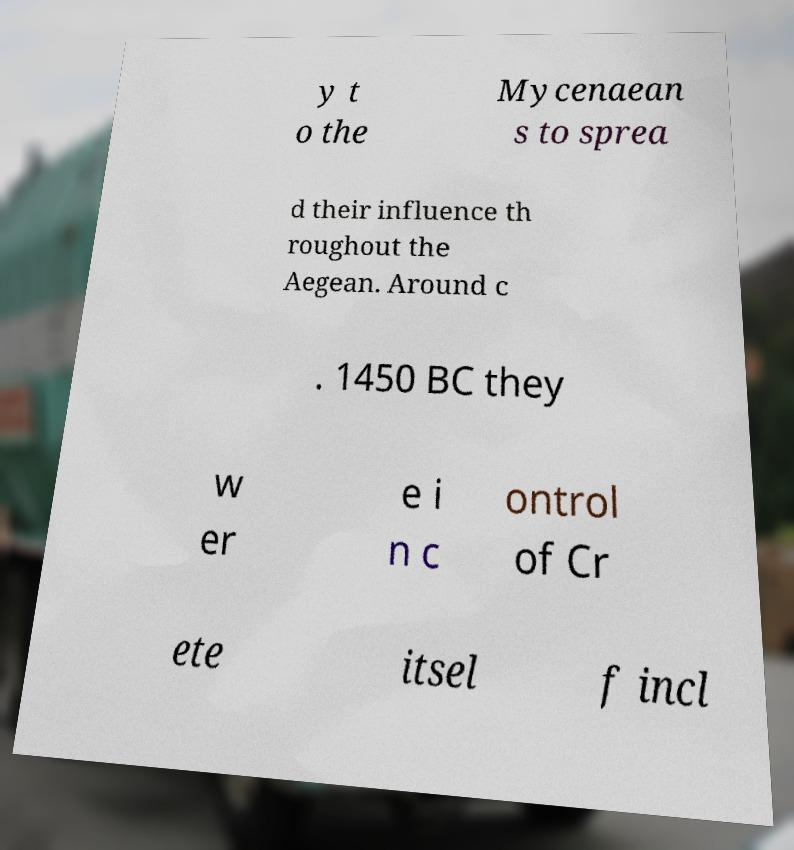There's text embedded in this image that I need extracted. Can you transcribe it verbatim? y t o the Mycenaean s to sprea d their influence th roughout the Aegean. Around c . 1450 BC they w er e i n c ontrol of Cr ete itsel f incl 